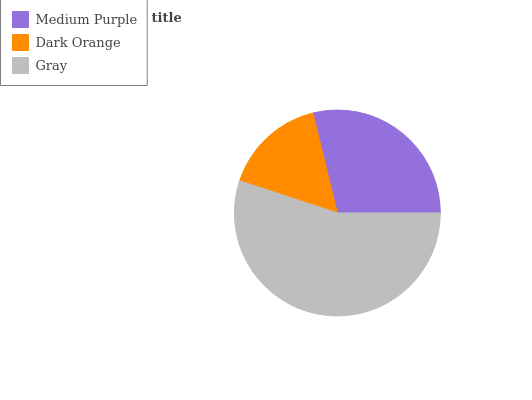Is Dark Orange the minimum?
Answer yes or no. Yes. Is Gray the maximum?
Answer yes or no. Yes. Is Gray the minimum?
Answer yes or no. No. Is Dark Orange the maximum?
Answer yes or no. No. Is Gray greater than Dark Orange?
Answer yes or no. Yes. Is Dark Orange less than Gray?
Answer yes or no. Yes. Is Dark Orange greater than Gray?
Answer yes or no. No. Is Gray less than Dark Orange?
Answer yes or no. No. Is Medium Purple the high median?
Answer yes or no. Yes. Is Medium Purple the low median?
Answer yes or no. Yes. Is Dark Orange the high median?
Answer yes or no. No. Is Dark Orange the low median?
Answer yes or no. No. 